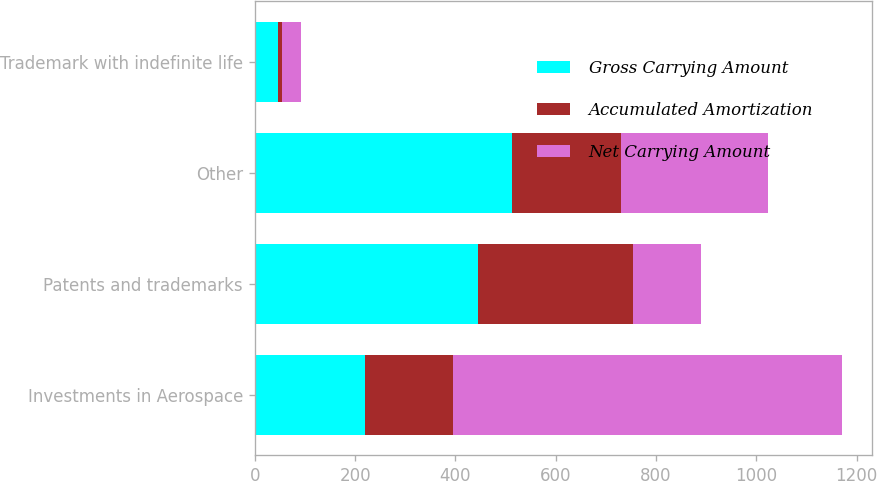Convert chart. <chart><loc_0><loc_0><loc_500><loc_500><stacked_bar_chart><ecel><fcel>Investments in Aerospace<fcel>Patents and trademarks<fcel>Other<fcel>Trademark with indefinite life<nl><fcel>Gross Carrying Amount<fcel>219<fcel>445<fcel>512<fcel>46<nl><fcel>Accumulated Amortization<fcel>176<fcel>310<fcel>219<fcel>9<nl><fcel>Net Carrying Amount<fcel>776<fcel>135<fcel>293<fcel>37<nl></chart> 